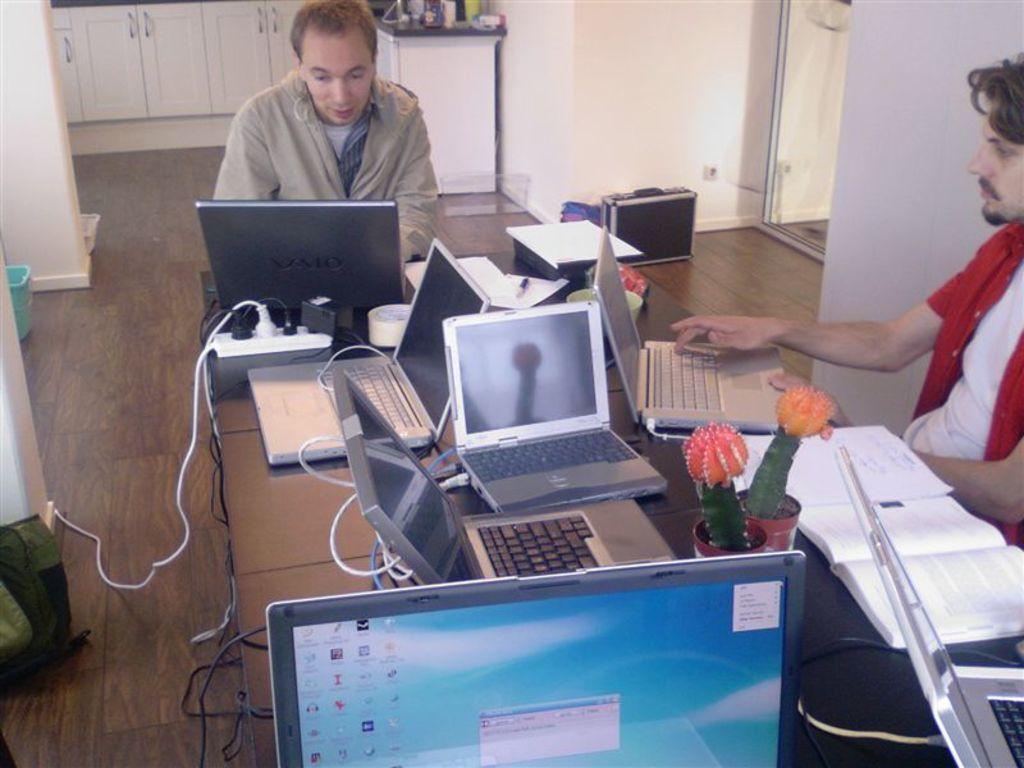What company makes these laptops?
Keep it short and to the point. Unanswerable. 